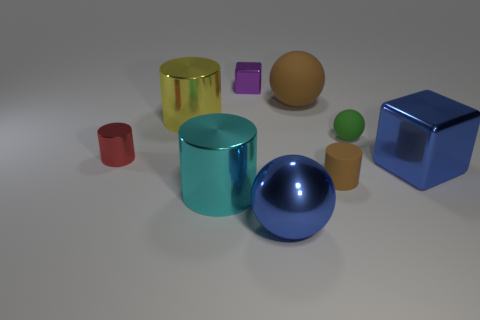Do the large metallic block and the large metallic sphere have the same color?
Your answer should be very brief. Yes. What number of other things are the same color as the small rubber sphere?
Keep it short and to the point. 0. The green matte object that is the same size as the red object is what shape?
Give a very brief answer. Sphere. How many large things are red cubes or red shiny objects?
Your response must be concise. 0. Is there a large blue thing behind the small purple block that is on the left side of the blue metallic thing to the left of the tiny brown cylinder?
Offer a very short reply. No. Are there any red shiny things of the same size as the yellow metal thing?
Make the answer very short. No. There is a brown object that is the same size as the red metal thing; what is its material?
Keep it short and to the point. Rubber. There is a metallic sphere; is it the same size as the cylinder behind the small green rubber ball?
Your answer should be compact. Yes. What number of metal objects are cyan objects or large cubes?
Make the answer very short. 2. How many large blue metal things are the same shape as the large cyan thing?
Give a very brief answer. 0. 